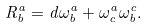<formula> <loc_0><loc_0><loc_500><loc_500>R _ { b } ^ { a } = d \omega _ { b } ^ { a } + \omega _ { c } ^ { a } \omega _ { b } ^ { c } .</formula> 